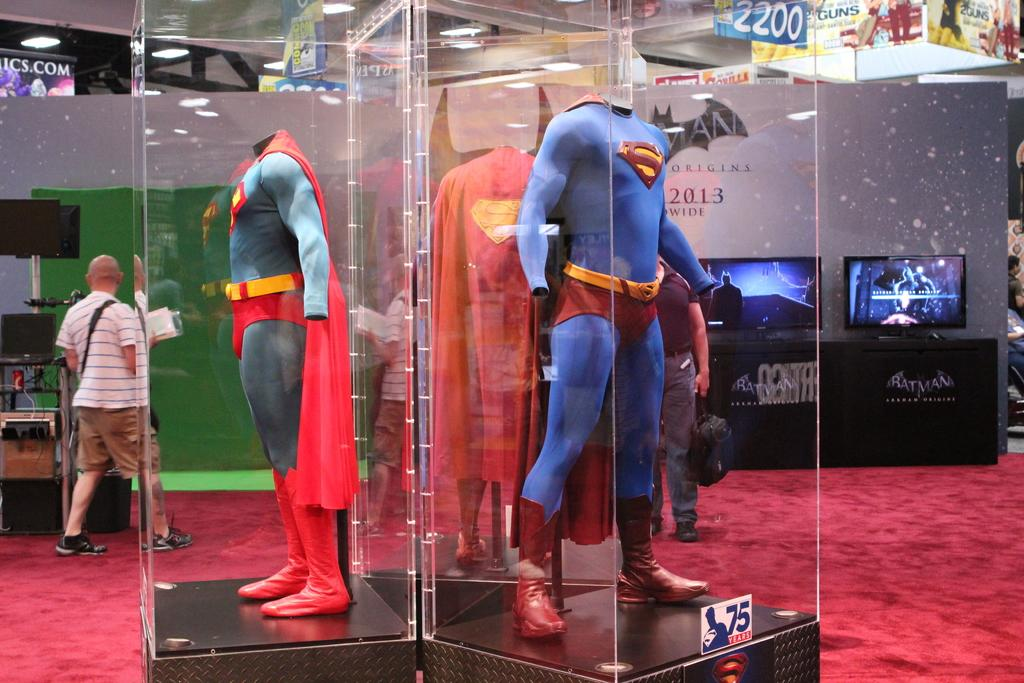Provide a one-sentence caption for the provided image. A Superman costume sits behind the glass and the year 2013 is shown in the back. 